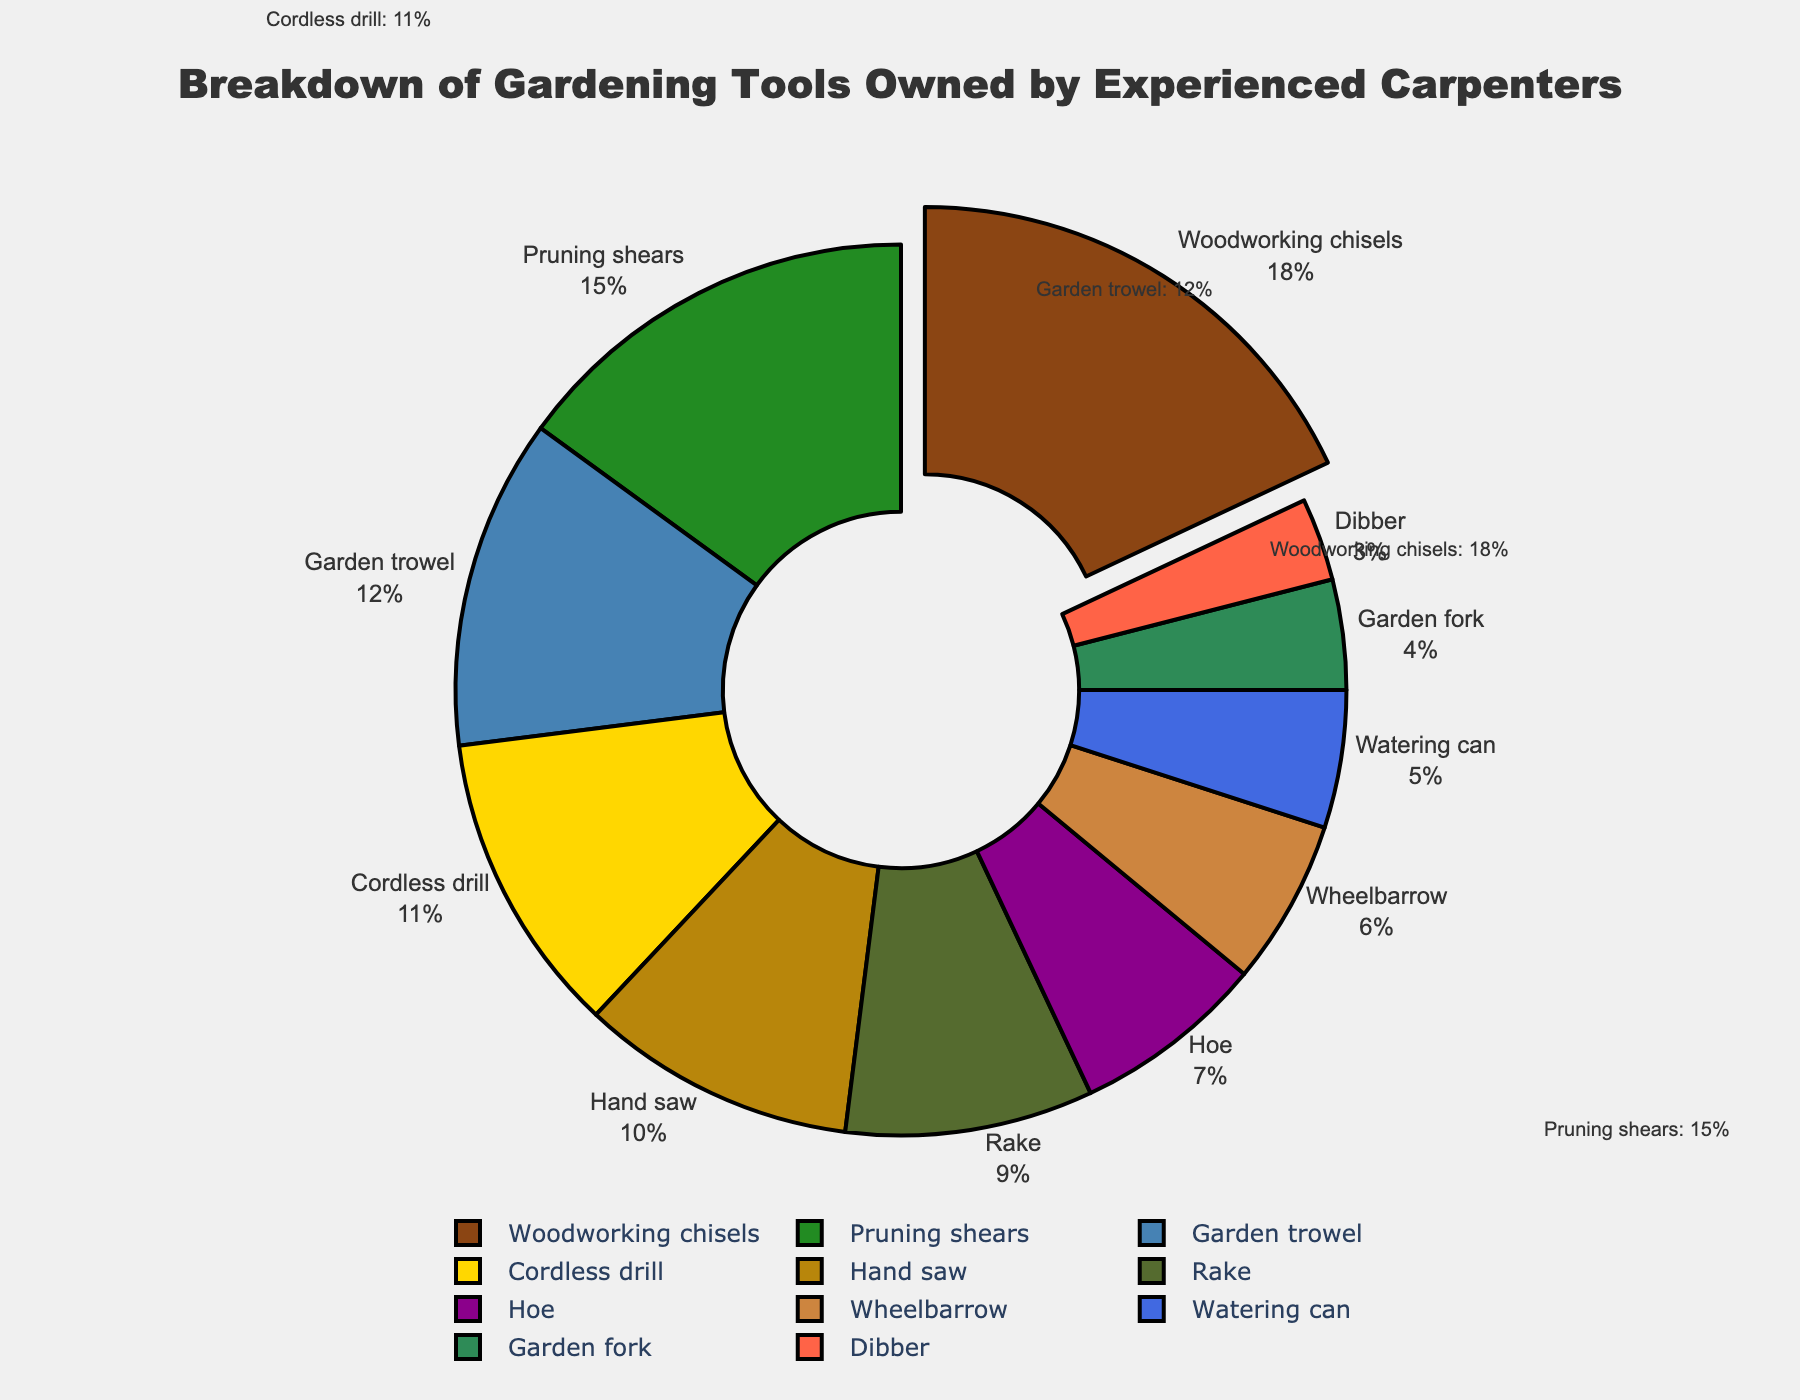Which tool has the highest percentage of ownership among experienced carpenters? The pie chart shows the percentage of various gardening tools owned by experienced carpenters. The largest segment represents woodworking chisels with 18% ownership.
Answer: Woodworking chisels What is the combined percentage of pruning shears and garden trowel? The pie chart shows pruning shears account for 15% and garden trowel for 12%. Adding these together, 15% + 12% = 27%.
Answer: 27% Which tools have ownership percentages less than 5%? The pie chart indicates that garden fork (4%) and dibber (3%) have percentages less than 5%.
Answer: Garden fork and dibber Is the ownership percentage of cordless drills greater than that of hand saws? By inspecting the pie chart, cordless drills have 11% ownership while hand saws have 10%. 11% is greater than 10%.
Answer: Yes What is the percentage difference between wheelbarrows and hoes? According to the pie chart, wheelbarrows have 6% and hoes have 7%. The difference is 7% - 6% = 1%.
Answer: 1% How does the ownership percentage of the rake compare to that of the hoe? The pie chart shows that the rake has an ownership percentage of 9%, which is higher than the hoe's 7%.
Answer: Rake is higher What fraction of the total percentage is made up by the top three tools combined? The top three tools are woodworking chisels (18%), pruning shears (15%), and garden trowel (12%). Adding these together gives 18% + 15% + 12% = 45%.
Answer: 45% Which tool is visually represented by the color closest to green? The pie chart uses various colors, and the color closest to green represents pruning shears, which have 15% ownership.
Answer: Pruning shears What is the cumulative percentage of the least three common tools? The three least common tools are garden fork (4%), dibber (3%), and watering can (5%). Adding them together gives 4% + 3% + 5% = 12%.
Answer: 12% Does the combined ownership of watering cans and cordless drills exceed that of woodworking chisels? Watering cans have 5% and cordless drills have 11%, summing to 16%. This is less than woodworking chisels which have 18%.
Answer: No 